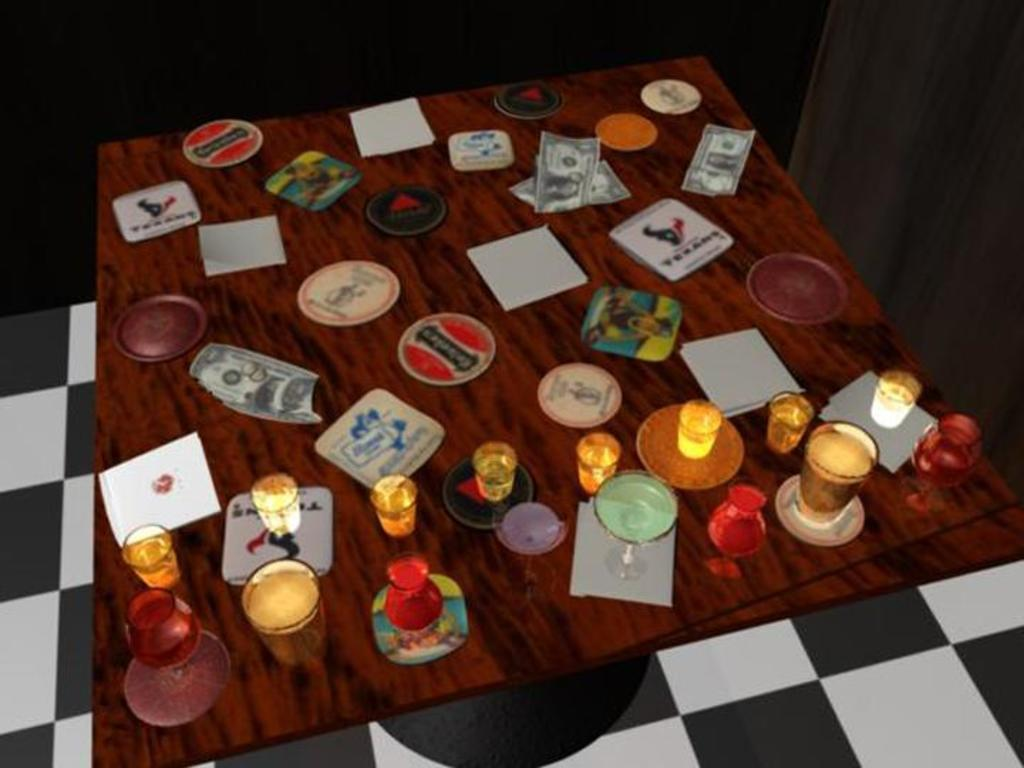What is the main object in the center of the image? There is a table in the center of the image. What can be seen on top of the table? There are glasses on the table, as well as other objects. What part of the room can be seen at the bottom of the image? The floor is visible at the bottom of the image. How many snails can be seen crawling on the table in the image? There are no snails present in the image. What type of shoe is visible on the floor in the image? There is no shoe visible on the floor in the image. 